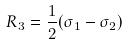Convert formula to latex. <formula><loc_0><loc_0><loc_500><loc_500>R _ { 3 } = \frac { 1 } { 2 } ( \sigma _ { 1 } - \sigma _ { 2 } )</formula> 